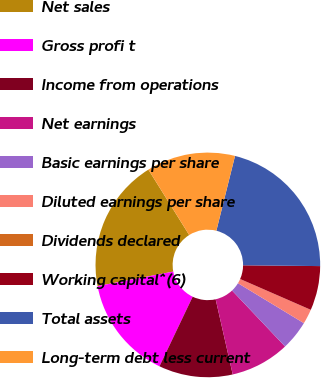<chart> <loc_0><loc_0><loc_500><loc_500><pie_chart><fcel>Net sales<fcel>Gross profi t<fcel>Income from operations<fcel>Net earnings<fcel>Basic earnings per share<fcel>Diluted earnings per share<fcel>Dividends declared<fcel>Working capital^(6)<fcel>Total assets<fcel>Long-term debt less current<nl><fcel>19.15%<fcel>14.89%<fcel>10.64%<fcel>8.51%<fcel>4.26%<fcel>2.13%<fcel>0.0%<fcel>6.38%<fcel>21.28%<fcel>12.77%<nl></chart> 